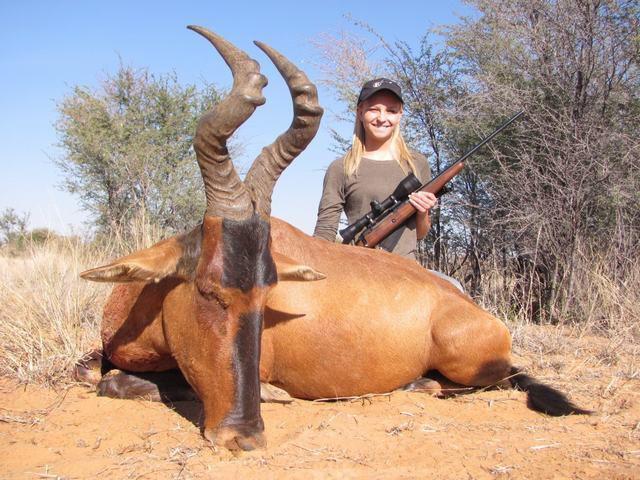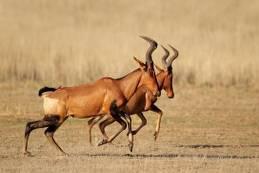The first image is the image on the left, the second image is the image on the right. Analyze the images presented: Is the assertion "A total of three animals with horns are standing still, and most have their heads turned to the camera." valid? Answer yes or no. No. The first image is the image on the left, the second image is the image on the right. Examine the images to the left and right. Is the description "The left and right image contains a total of three elk and the single elk facing left." accurate? Answer yes or no. No. 